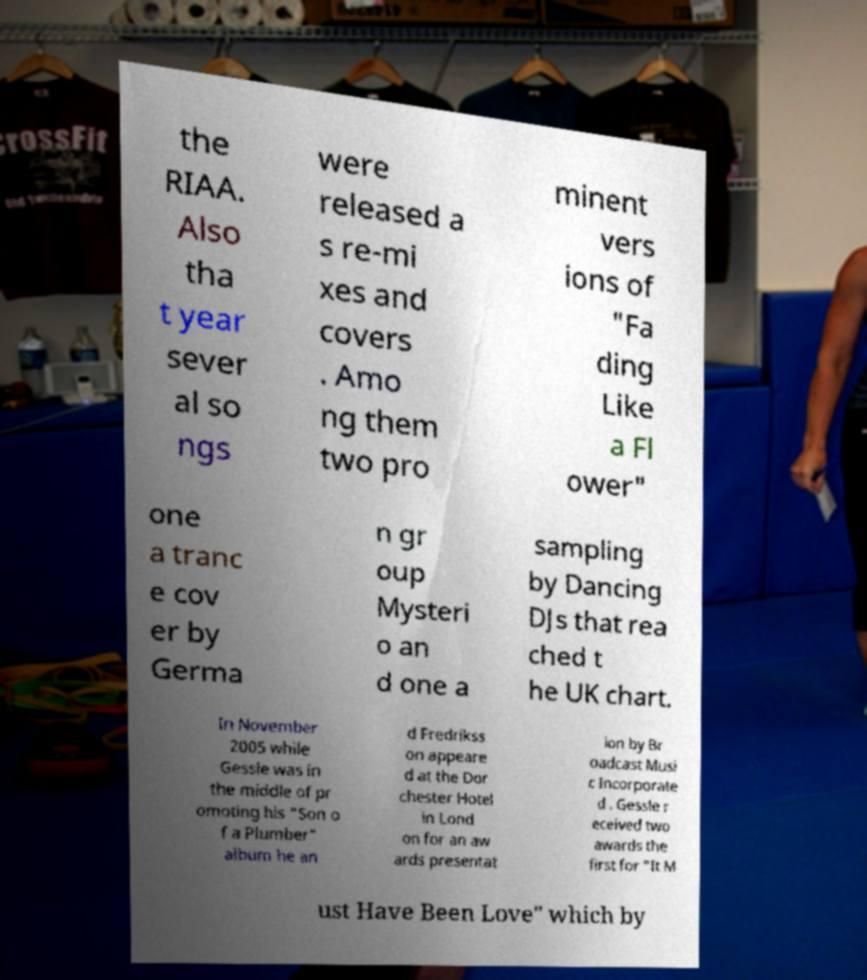There's text embedded in this image that I need extracted. Can you transcribe it verbatim? the RIAA. Also tha t year sever al so ngs were released a s re-mi xes and covers . Amo ng them two pro minent vers ions of "Fa ding Like a Fl ower" one a tranc e cov er by Germa n gr oup Mysteri o an d one a sampling by Dancing DJs that rea ched t he UK chart. In November 2005 while Gessle was in the middle of pr omoting his "Son o f a Plumber" album he an d Fredrikss on appeare d at the Dor chester Hotel in Lond on for an aw ards presentat ion by Br oadcast Musi c Incorporate d . Gessle r eceived two awards the first for "It M ust Have Been Love" which by 